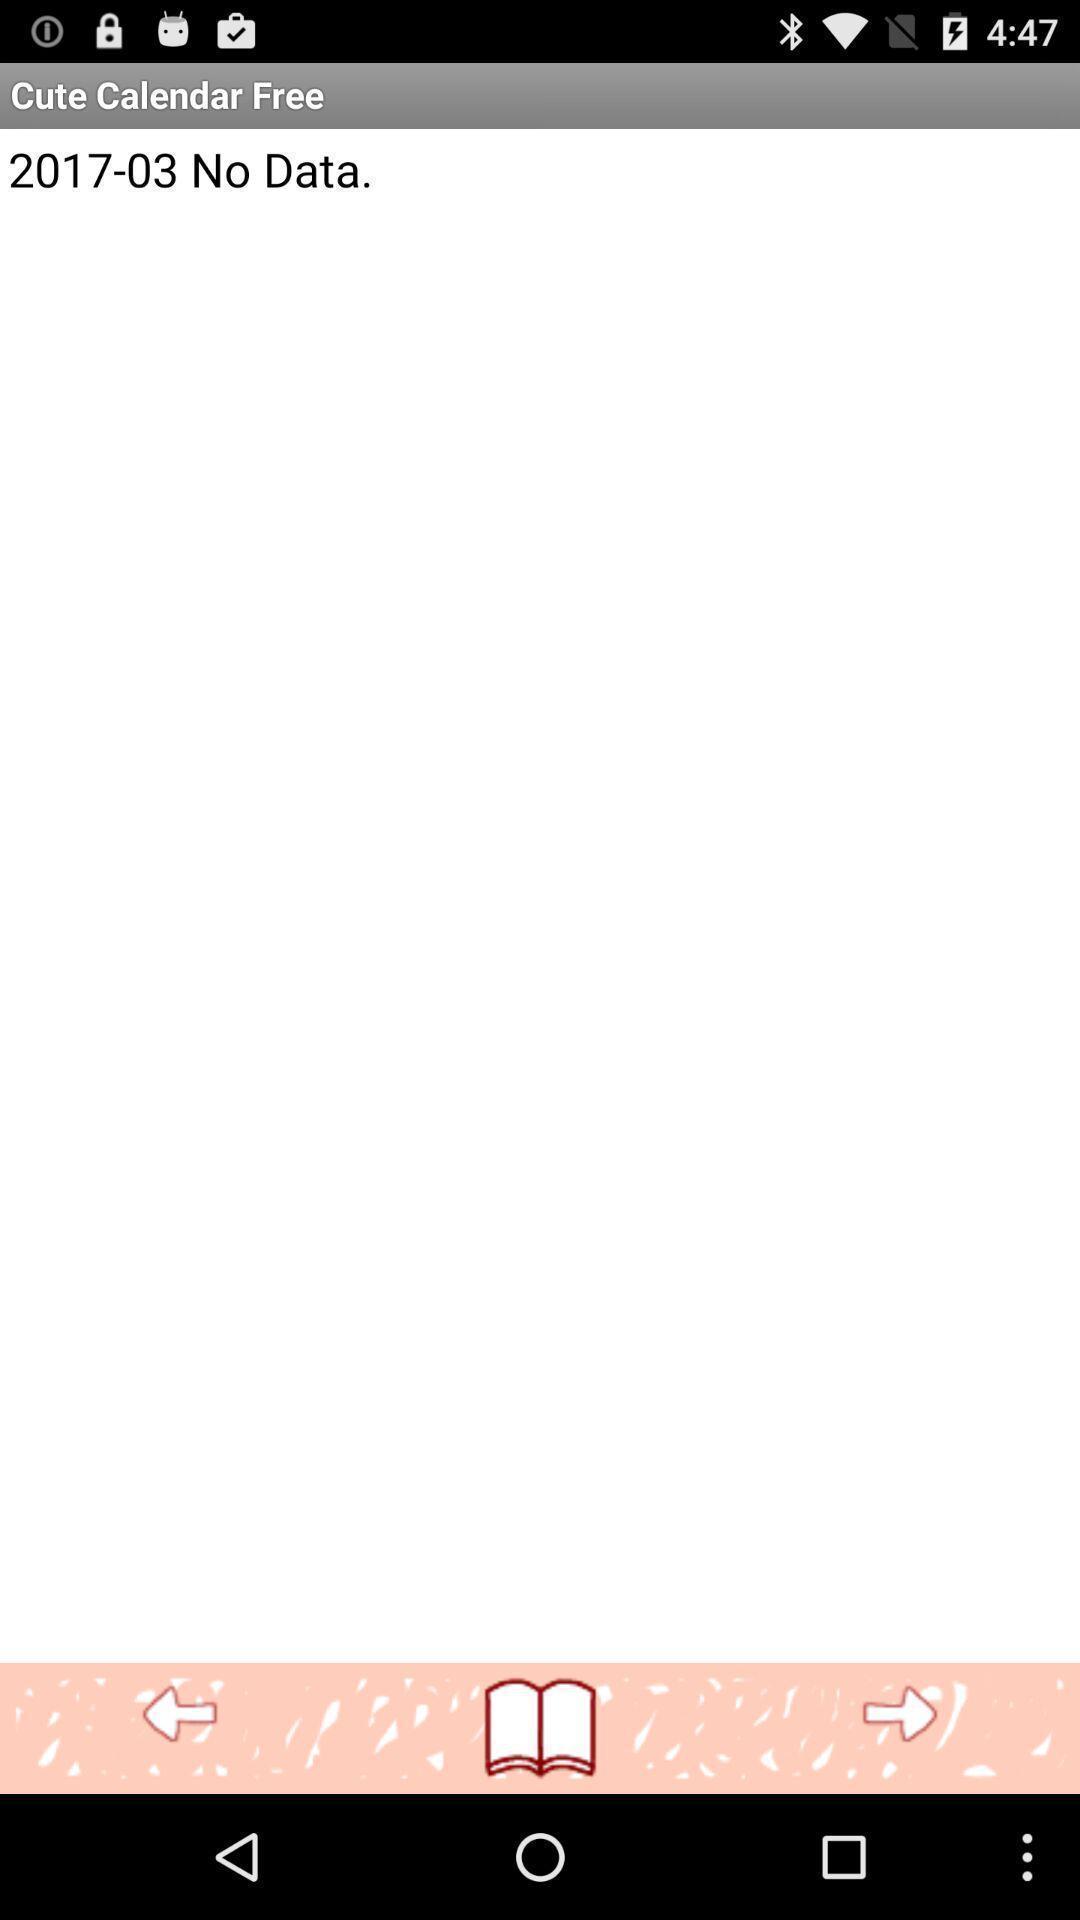Summarize the main components in this picture. Page showing interface for a calendar based planner app. 